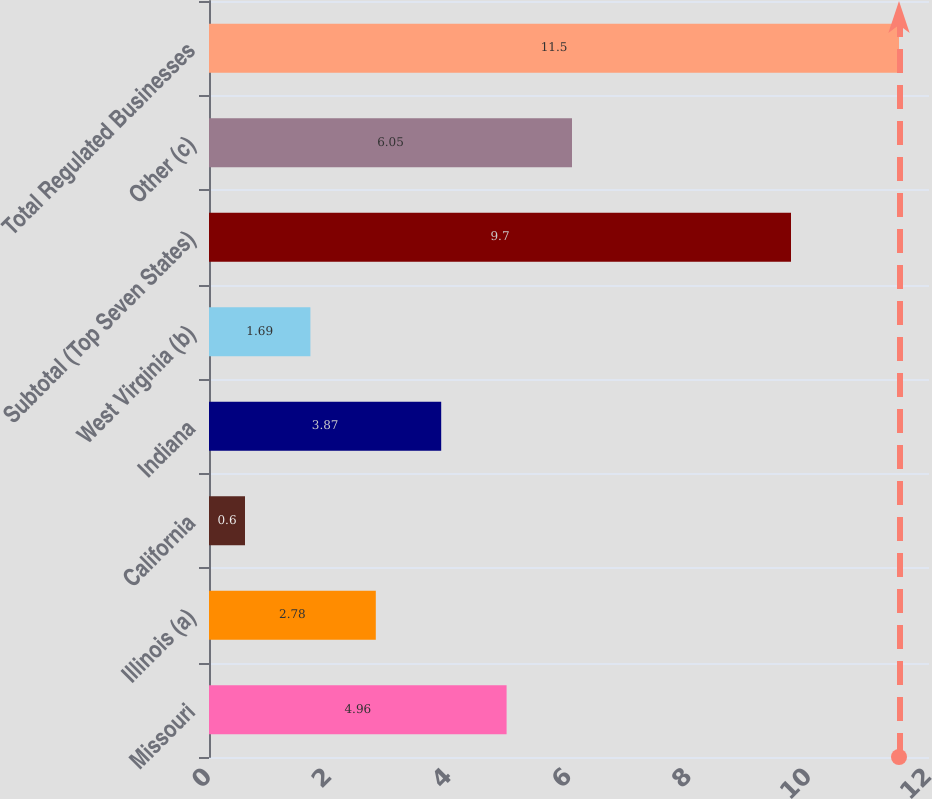Convert chart to OTSL. <chart><loc_0><loc_0><loc_500><loc_500><bar_chart><fcel>Missouri<fcel>Illinois (a)<fcel>California<fcel>Indiana<fcel>West Virginia (b)<fcel>Subtotal (Top Seven States)<fcel>Other (c)<fcel>Total Regulated Businesses<nl><fcel>4.96<fcel>2.78<fcel>0.6<fcel>3.87<fcel>1.69<fcel>9.7<fcel>6.05<fcel>11.5<nl></chart> 